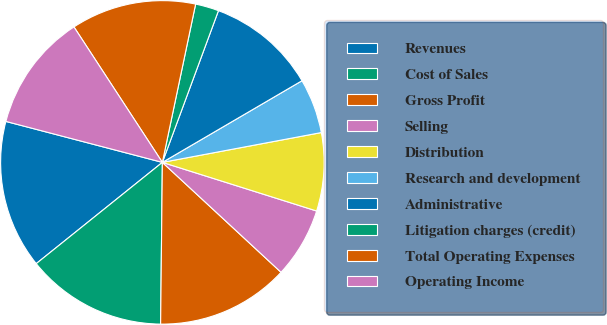Convert chart. <chart><loc_0><loc_0><loc_500><loc_500><pie_chart><fcel>Revenues<fcel>Cost of Sales<fcel>Gross Profit<fcel>Selling<fcel>Distribution<fcel>Research and development<fcel>Administrative<fcel>Litigation charges (credit)<fcel>Total Operating Expenses<fcel>Operating Income<nl><fcel>14.84%<fcel>14.06%<fcel>13.28%<fcel>7.03%<fcel>7.81%<fcel>5.47%<fcel>10.94%<fcel>2.34%<fcel>12.5%<fcel>11.72%<nl></chart> 